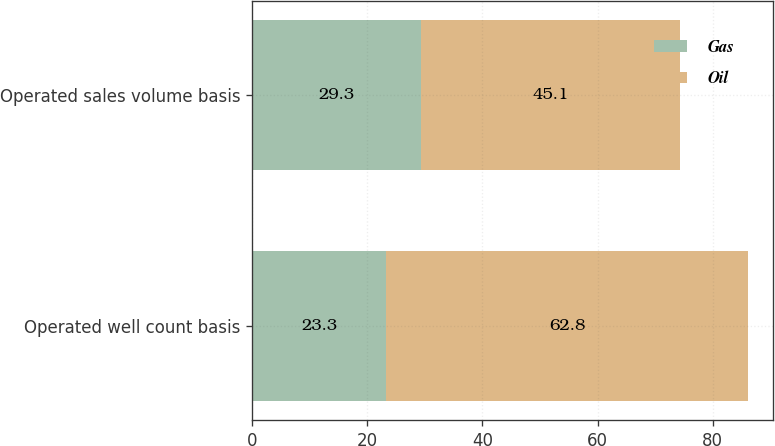Convert chart. <chart><loc_0><loc_0><loc_500><loc_500><stacked_bar_chart><ecel><fcel>Operated well count basis<fcel>Operated sales volume basis<nl><fcel>Gas<fcel>23.3<fcel>29.3<nl><fcel>Oil<fcel>62.8<fcel>45.1<nl></chart> 